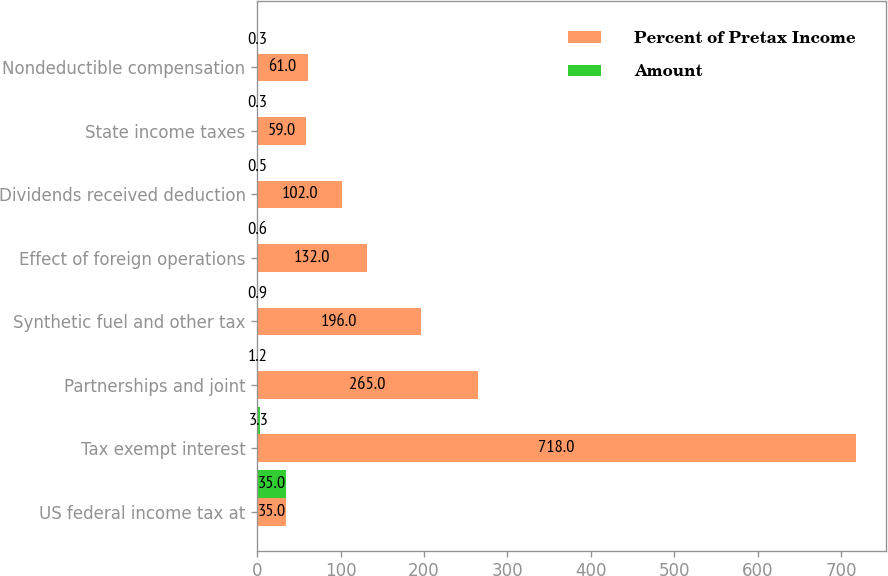Convert chart. <chart><loc_0><loc_0><loc_500><loc_500><stacked_bar_chart><ecel><fcel>US federal income tax at<fcel>Tax exempt interest<fcel>Partnerships and joint<fcel>Synthetic fuel and other tax<fcel>Effect of foreign operations<fcel>Dividends received deduction<fcel>State income taxes<fcel>Nondeductible compensation<nl><fcel>Percent of Pretax Income<fcel>35<fcel>718<fcel>265<fcel>196<fcel>132<fcel>102<fcel>59<fcel>61<nl><fcel>Amount<fcel>35<fcel>3.3<fcel>1.2<fcel>0.9<fcel>0.6<fcel>0.5<fcel>0.3<fcel>0.3<nl></chart> 